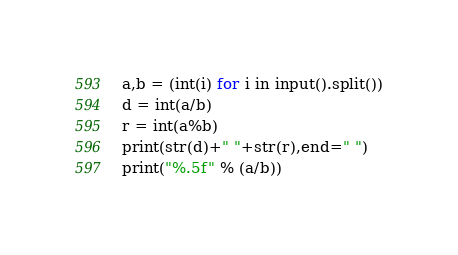Convert code to text. <code><loc_0><loc_0><loc_500><loc_500><_Python_>a,b = (int(i) for i in input().split())
d = int(a/b)
r = int(a%b)
print(str(d)+" "+str(r),end=" ")
print("%.5f" % (a/b))</code> 